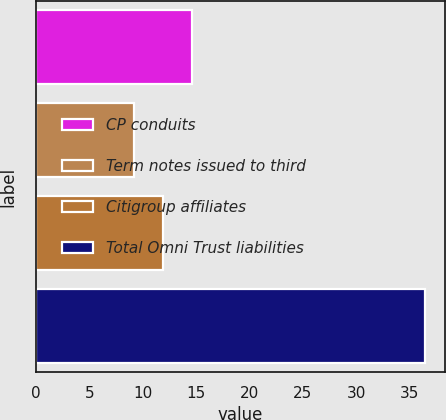Convert chart to OTSL. <chart><loc_0><loc_0><loc_500><loc_500><bar_chart><fcel>CP conduits<fcel>Term notes issued to third<fcel>Citigroup affiliates<fcel>Total Omni Trust liabilities<nl><fcel>14.66<fcel>9.2<fcel>11.93<fcel>36.5<nl></chart> 